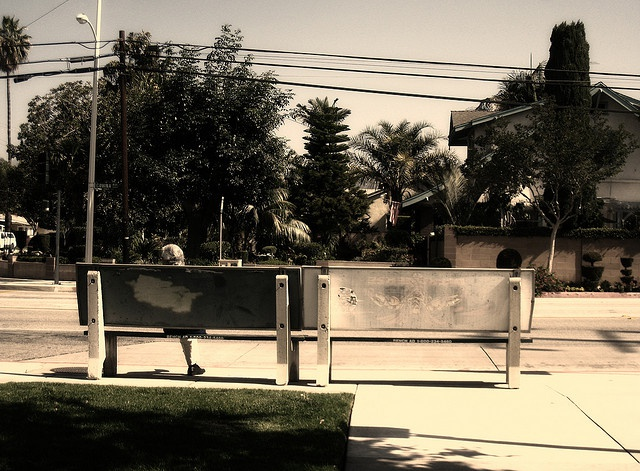Describe the objects in this image and their specific colors. I can see bench in darkgray, black, gray, and tan tones, bench in darkgray and tan tones, people in darkgray, black, and lightyellow tones, car in darkgray, black, gray, and darkgreen tones, and car in darkgray, beige, black, and gray tones in this image. 